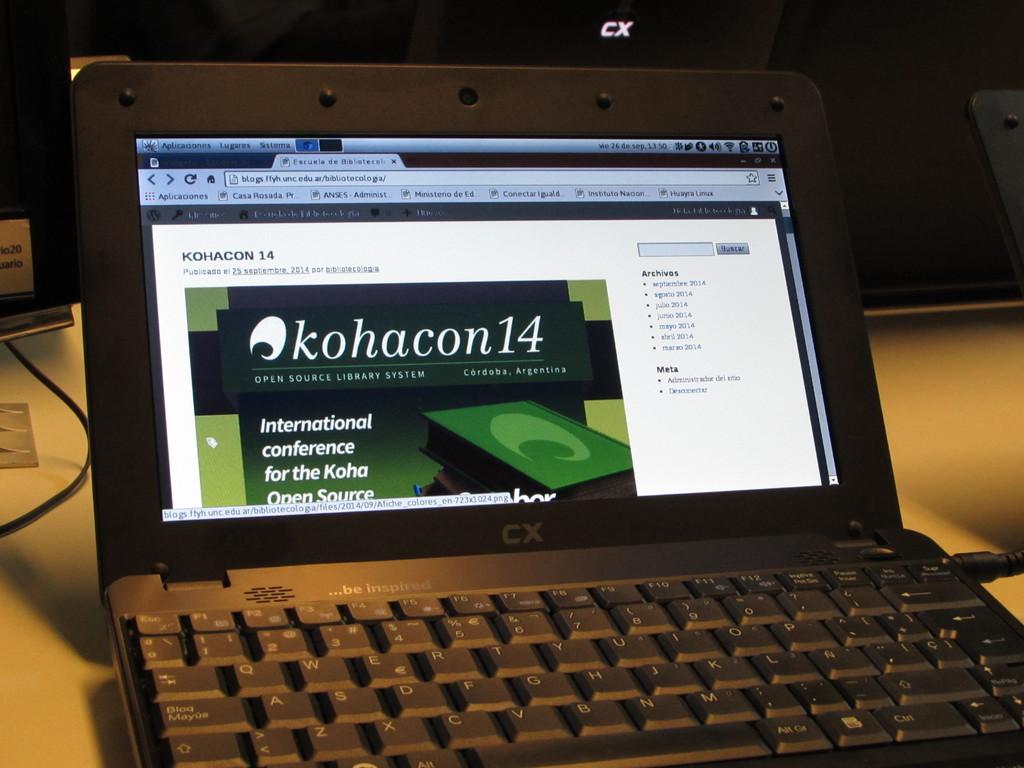What program is this?
Give a very brief answer. Kohacon14. Is this conference only in one nation?
Provide a short and direct response. No. 